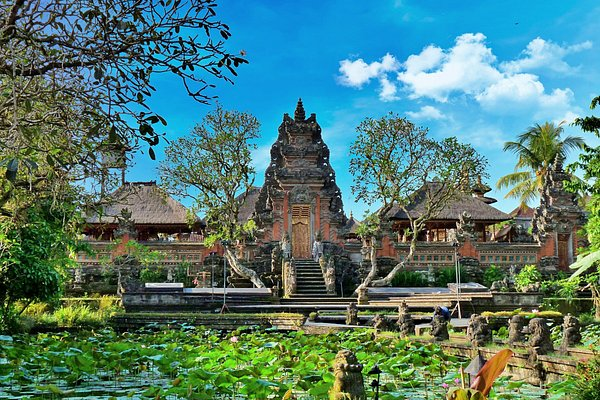Imagine this scene in an alternate reality where everything is made of glass. What do you see? In an alternate reality where everything is made of glass, the Ubud Water Palace would transform into a shimmering, translucent marvel. The buildings, with their intricate glass carvings, would catch and refract the sunlight, casting a rainbow of colors across the landscape. The pond, now a crystal-clear basin, would reflect the glass structures in mesmerizing detail. The lush greenery, turned into delicate glass foliage, would glisten like gems in the light. Every step taken on this glass terrain would produce a melodic chime as if nature itself were playing a gentle symphony. The atmosphere would be ethereal and magical, a breathtaking spectacle of light and color that feels like stepping into a fantastical dreamscape. 